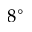<formula> <loc_0><loc_0><loc_500><loc_500>8 ^ { \circ }</formula> 